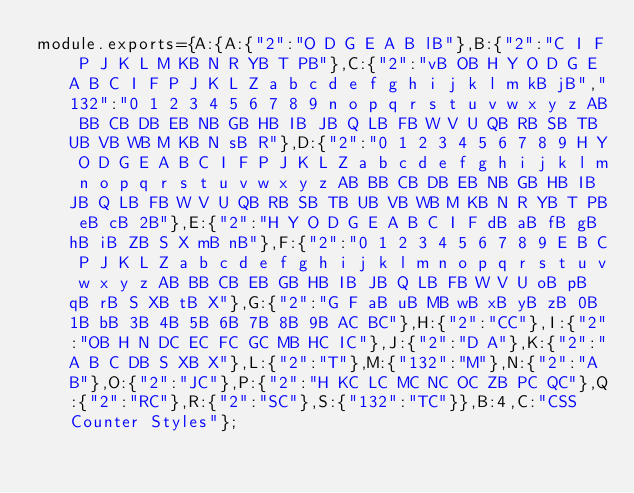Convert code to text. <code><loc_0><loc_0><loc_500><loc_500><_JavaScript_>module.exports={A:{A:{"2":"O D G E A B lB"},B:{"2":"C I F P J K L M KB N R YB T PB"},C:{"2":"vB OB H Y O D G E A B C I F P J K L Z a b c d e f g h i j k l m kB jB","132":"0 1 2 3 4 5 6 7 8 9 n o p q r s t u v w x y z AB BB CB DB EB NB GB HB IB JB Q LB FB W V U QB RB SB TB UB VB WB M KB N sB R"},D:{"2":"0 1 2 3 4 5 6 7 8 9 H Y O D G E A B C I F P J K L Z a b c d e f g h i j k l m n o p q r s t u v w x y z AB BB CB DB EB NB GB HB IB JB Q LB FB W V U QB RB SB TB UB VB WB M KB N R YB T PB eB cB 2B"},E:{"2":"H Y O D G E A B C I F dB aB fB gB hB iB ZB S X mB nB"},F:{"2":"0 1 2 3 4 5 6 7 8 9 E B C P J K L Z a b c d e f g h i j k l m n o p q r s t u v w x y z AB BB CB EB GB HB IB JB Q LB FB W V U oB pB qB rB S XB tB X"},G:{"2":"G F aB uB MB wB xB yB zB 0B 1B bB 3B 4B 5B 6B 7B 8B 9B AC BC"},H:{"2":"CC"},I:{"2":"OB H N DC EC FC GC MB HC IC"},J:{"2":"D A"},K:{"2":"A B C DB S XB X"},L:{"2":"T"},M:{"132":"M"},N:{"2":"A B"},O:{"2":"JC"},P:{"2":"H KC LC MC NC OC ZB PC QC"},Q:{"2":"RC"},R:{"2":"SC"},S:{"132":"TC"}},B:4,C:"CSS Counter Styles"};
</code> 